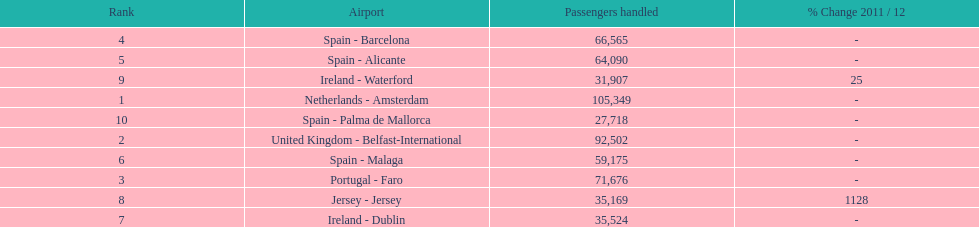How many passengers are going to or coming from spain? 217,548. 